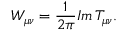Convert formula to latex. <formula><loc_0><loc_0><loc_500><loc_500>W _ { \mu \nu } = \frac { 1 } { 2 \pi } I m \, T _ { \mu \nu } .</formula> 